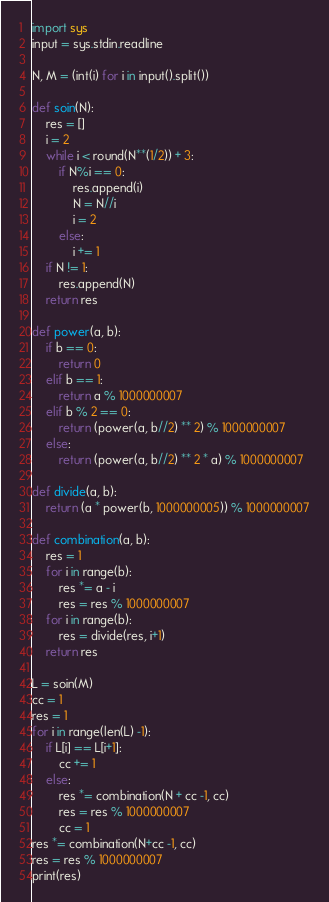Convert code to text. <code><loc_0><loc_0><loc_500><loc_500><_Python_>import sys
input = sys.stdin.readline

N, M = (int(i) for i in input().split())

def soin(N):
	res = []
	i = 2
	while i < round(N**(1/2)) + 3:
		if N%i == 0:
			res.append(i)
			N = N//i
			i = 2
		else:
			i += 1
	if N != 1:
		res.append(N)
	return res

def power(a, b):
	if b == 0:
		return 0
	elif b == 1:
		return a % 1000000007
	elif b % 2 == 0:
		return (power(a, b//2) ** 2) % 1000000007
	else:
		return (power(a, b//2) ** 2 * a) % 1000000007

def divide(a, b):
	return (a * power(b, 1000000005)) % 1000000007

def combination(a, b):
	res = 1
	for i in range(b):
		res *= a - i
		res = res % 1000000007
	for i in range(b):
		res = divide(res, i+1)
	return res
	
L = soin(M)
cc = 1
res = 1
for i in range(len(L) -1):
	if L[i] == L[i+1]:
		cc += 1
	else:
		res *= combination(N + cc -1, cc)
		res = res % 1000000007
		cc = 1
res *= combination(N+cc -1, cc)
res = res % 1000000007
print(res)</code> 